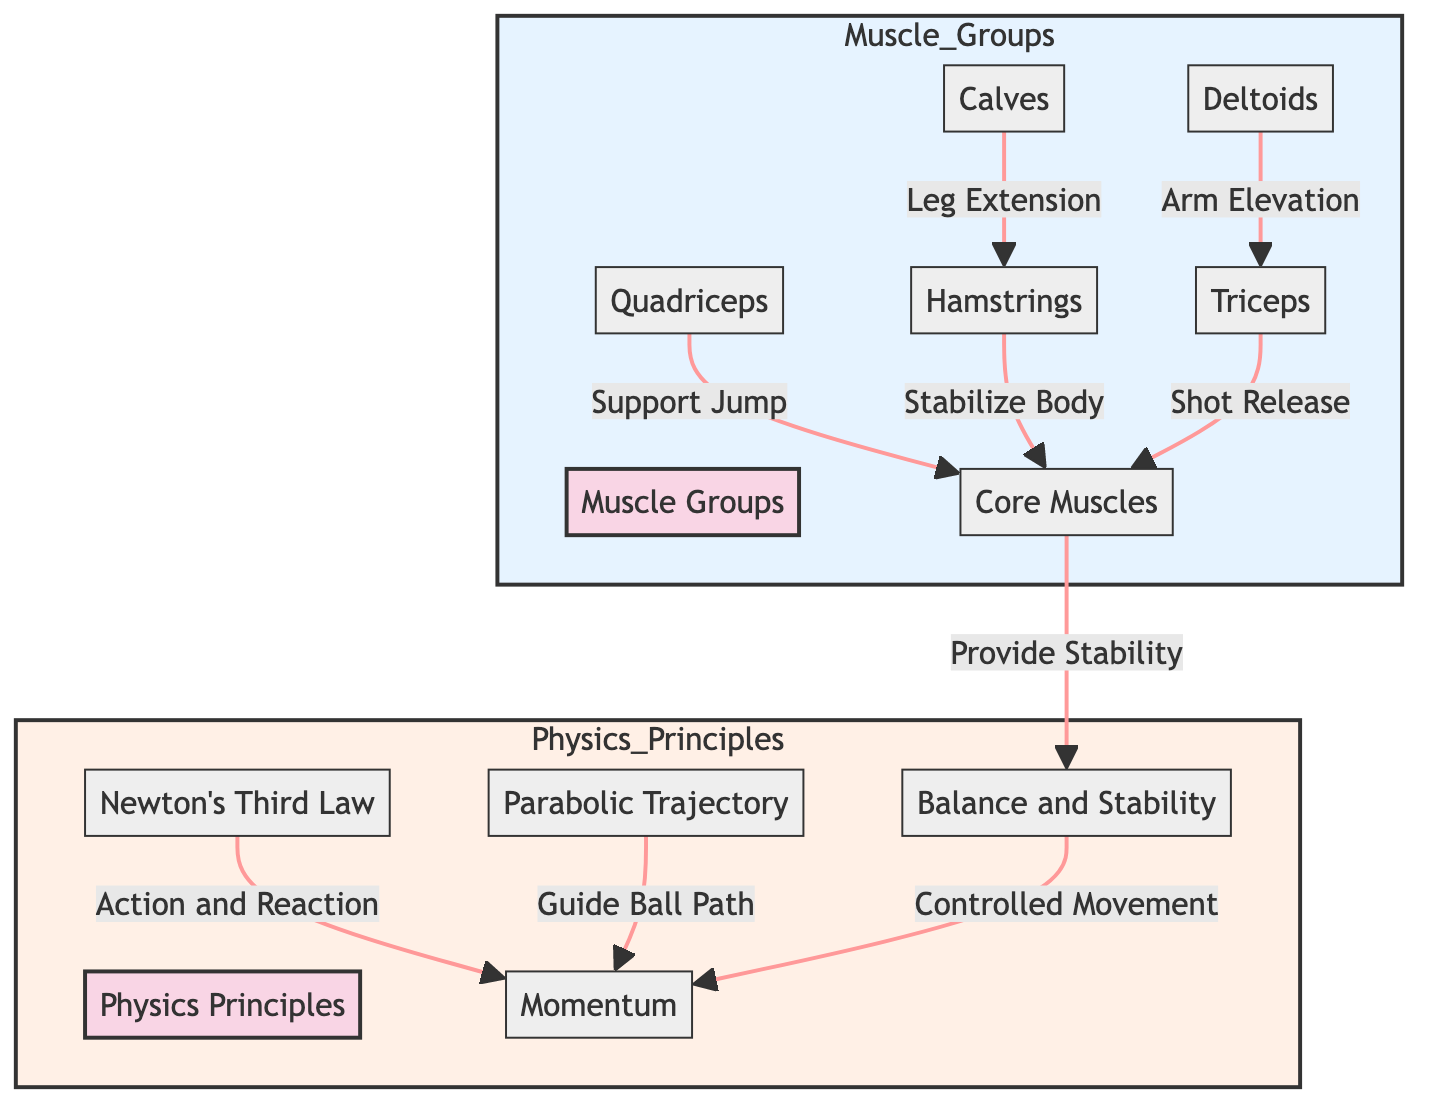What are the muscle groups involved in a jump shot? The diagram lists six muscle groups involved: Quadriceps, Calves, Hamstrings, Deltoids, Triceps, and Core Muscles. These are clearly labeled in the "Muscle Groups" section.
Answer: Quadriceps, Calves, Hamstrings, Deltoids, Triceps, Core Muscles What does the Calves muscle contribute to the jump shot? The diagram shows an arrow from Calves to Hamstrings labeled "Leg Extension," indicating that the Calves contribute this function during the jump shot.
Answer: Leg Extension How many physics principles are involved in a jump shot? The diagram illustrates four physics principles: Newton's Third Law, Parabolic Trajectory, Momentum, and Balance and Stability. These are listed in the "Physics Principles" section.
Answer: Four What role do the Quadriceps play in the jump shot? The diagram has an arrow from Quadriceps to Core, labeled "Support Jump." This indicates that the Quadriceps provide support during the jumping action.
Answer: Support Jump What is the relationship between Balanced Stability and Momentum? The diagram shows a connection from Balance to Momentum labeled "Controlled Movement." This means that balanced stability is essential for maintaining momentum during the jump shot.
Answer: Controlled Movement How do Newton's Third Law and Parabolic Trajectory relate to momentum? The diagram shows arrows from both Newton's Third Law and Parabolic Trajectory leading to Momentum. This indicates that both principles influence momentum in the jump shot.
Answer: Influence Momentum Which muscle stabilizes the body during the jump? The diagram indicates that Hamstrings stabilize the body, as shown by the connecting arrow labeled "Stabilize Body" directed toward Core.
Answer: Hamstrings In terms of biomechanics, which muscle group provides stability? The diagram clearly states that Core Muscles provide stability, as indicated by an arrow leading to Balance, which is crucial for effective movement during a jump shot.
Answer: Core Muscles 